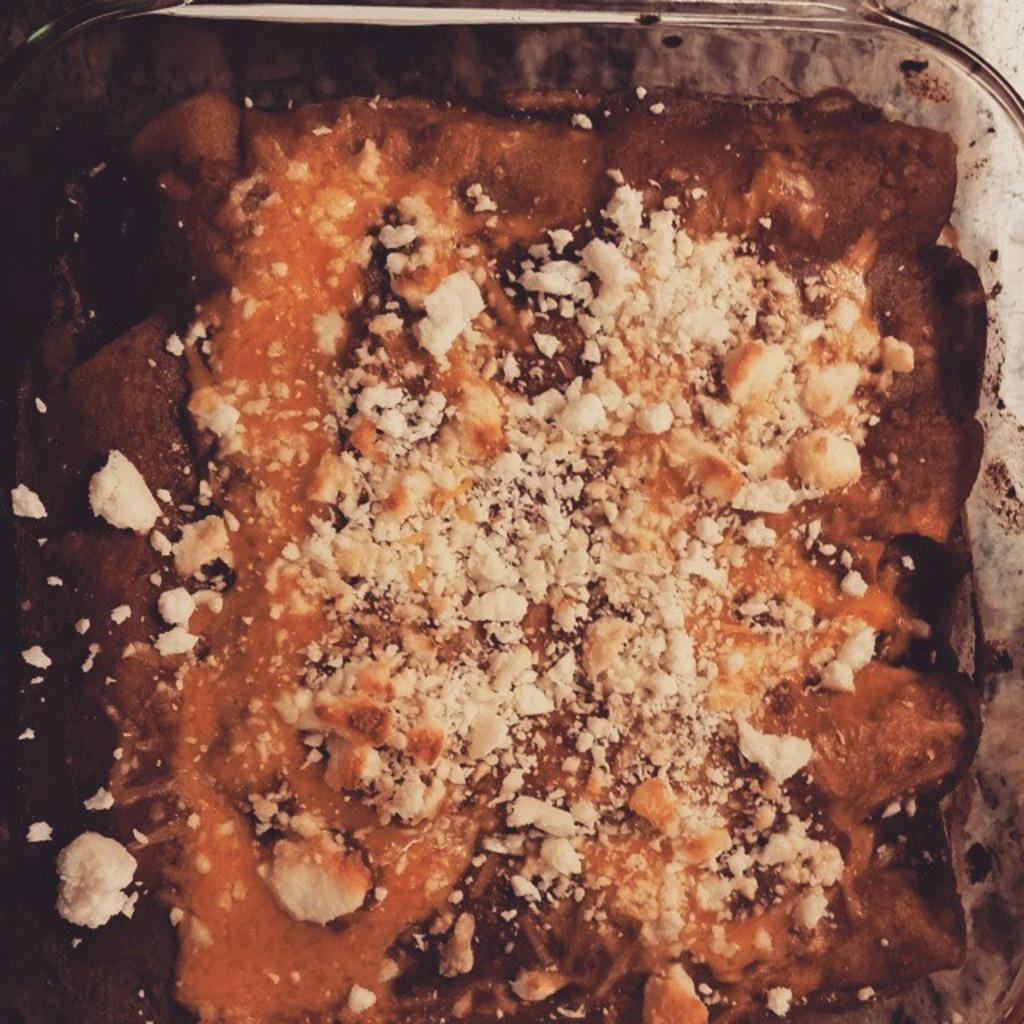What is the main subject of the image? There is a food item in the image. How is the food item presented? The food item is on a glass vessel. What can be observed on the food item? There are white color things on the food item. How does the team use the rake in the image? There is no team or rake present in the image; it features a food item on a glass vessel with white color things on it. 